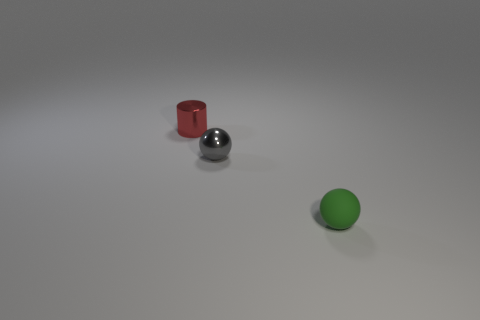Subtract all gray balls. How many balls are left? 1 Add 1 large green rubber cubes. How many objects exist? 4 Subtract 0 brown blocks. How many objects are left? 3 Subtract all cylinders. How many objects are left? 2 Subtract 1 cylinders. How many cylinders are left? 0 Subtract all blue balls. Subtract all blue cylinders. How many balls are left? 2 Subtract all red cubes. How many green balls are left? 1 Subtract all purple matte cubes. Subtract all tiny things. How many objects are left? 0 Add 3 tiny cylinders. How many tiny cylinders are left? 4 Add 3 blue rubber cylinders. How many blue rubber cylinders exist? 3 